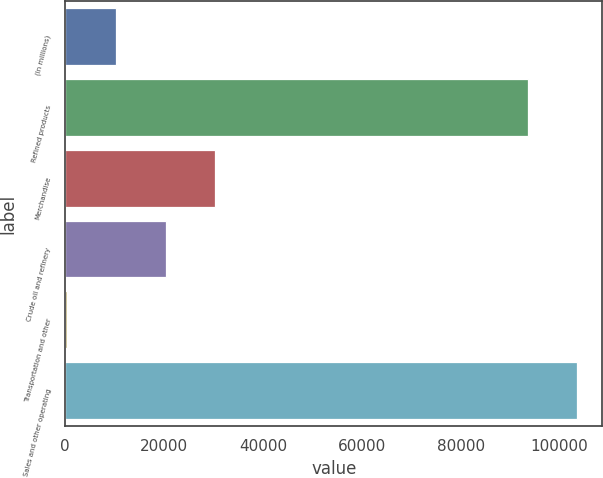Convert chart. <chart><loc_0><loc_0><loc_500><loc_500><bar_chart><fcel>(In millions)<fcel>Refined products<fcel>Merchandise<fcel>Crude oil and refinery<fcel>Transportation and other<fcel>Sales and other operating<nl><fcel>10325.6<fcel>93520<fcel>30288.8<fcel>20307.2<fcel>344<fcel>103502<nl></chart> 